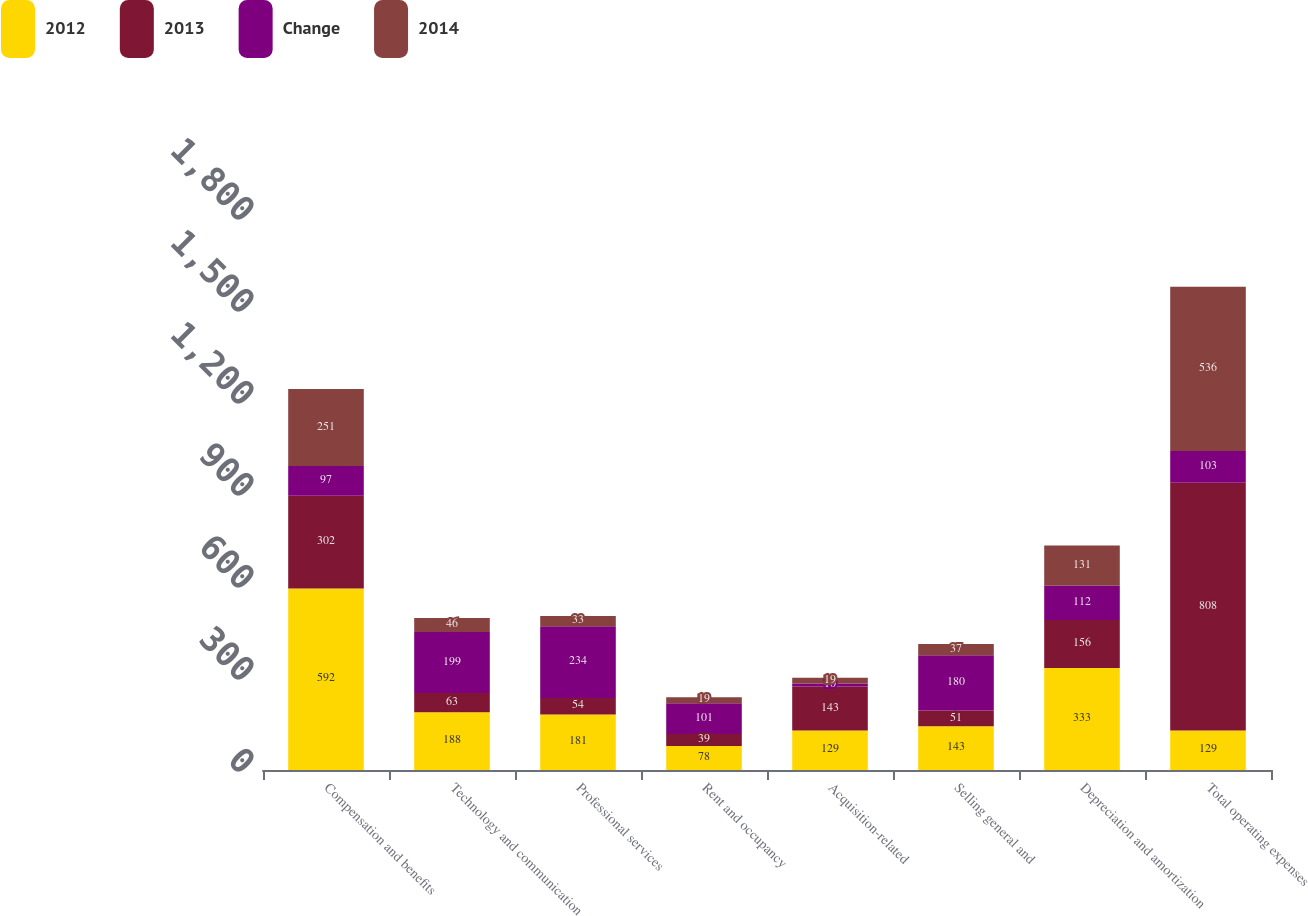<chart> <loc_0><loc_0><loc_500><loc_500><stacked_bar_chart><ecel><fcel>Compensation and benefits<fcel>Technology and communication<fcel>Professional services<fcel>Rent and occupancy<fcel>Acquisition-related<fcel>Selling general and<fcel>Depreciation and amortization<fcel>Total operating expenses<nl><fcel>2012<fcel>592<fcel>188<fcel>181<fcel>78<fcel>129<fcel>143<fcel>333<fcel>129<nl><fcel>2013<fcel>302<fcel>63<fcel>54<fcel>39<fcel>143<fcel>51<fcel>156<fcel>808<nl><fcel>Change<fcel>97<fcel>199<fcel>234<fcel>101<fcel>10<fcel>180<fcel>112<fcel>103<nl><fcel>2014<fcel>251<fcel>46<fcel>33<fcel>19<fcel>19<fcel>37<fcel>131<fcel>536<nl></chart> 